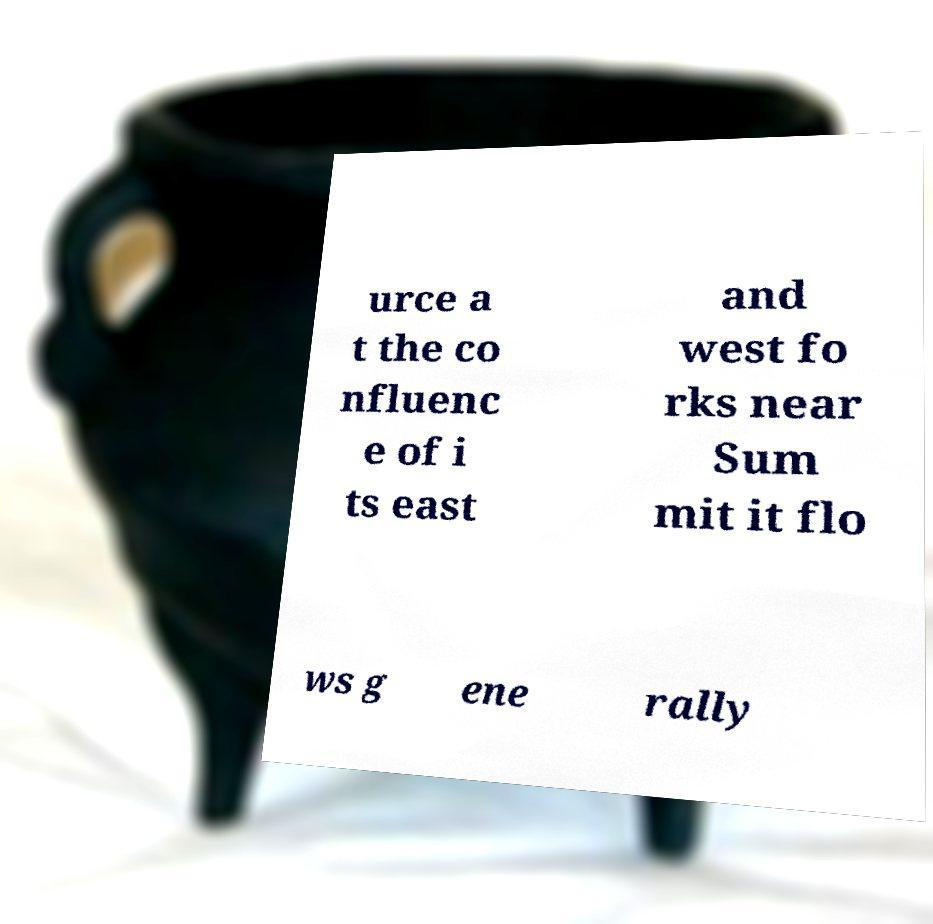Please read and relay the text visible in this image. What does it say? urce a t the co nfluenc e of i ts east and west fo rks near Sum mit it flo ws g ene rally 